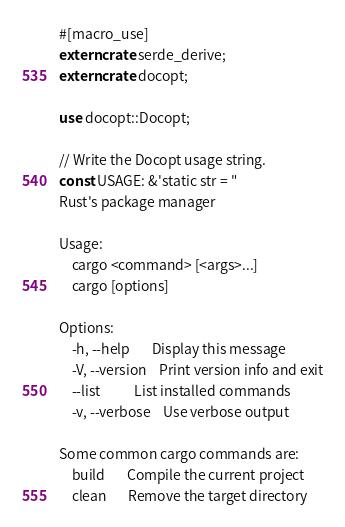<code> <loc_0><loc_0><loc_500><loc_500><_Rust_>#[macro_use]
extern crate serde_derive;
extern crate docopt;

use docopt::Docopt;

// Write the Docopt usage string.
const USAGE: &'static str = "
Rust's package manager

Usage:
    cargo <command> [<args>...]
    cargo [options]

Options:
    -h, --help       Display this message
    -V, --version    Print version info and exit
    --list           List installed commands
    -v, --verbose    Use verbose output

Some common cargo commands are:
    build       Compile the current project
    clean       Remove the target directory</code> 